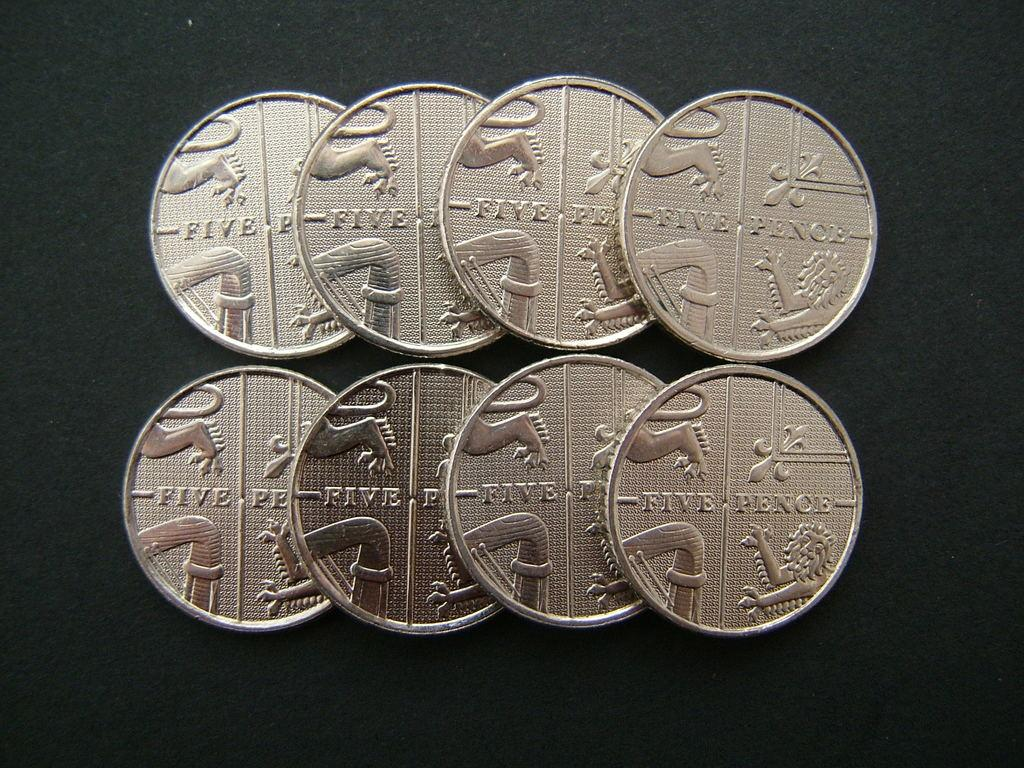<image>
Write a terse but informative summary of the picture. Eight, five pence coins are laying in tow rows on a table 